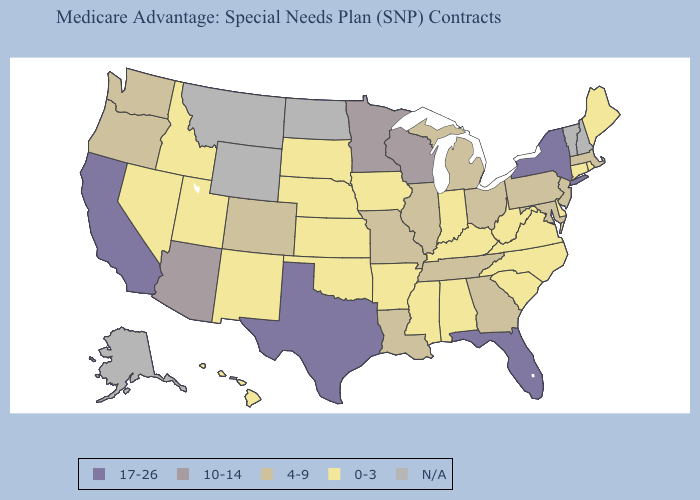What is the value of Kentucky?
Answer briefly. 0-3. Among the states that border Georgia , does Florida have the highest value?
Keep it brief. Yes. Does Florida have the lowest value in the USA?
Short answer required. No. What is the lowest value in states that border West Virginia?
Quick response, please. 0-3. Which states have the lowest value in the West?
Give a very brief answer. Hawaii, Idaho, New Mexico, Nevada, Utah. Name the states that have a value in the range 17-26?
Short answer required. California, Florida, New York, Texas. Name the states that have a value in the range N/A?
Keep it brief. Alaska, Montana, North Dakota, New Hampshire, Vermont, Wyoming. Does the map have missing data?
Short answer required. Yes. Which states have the lowest value in the MidWest?
Write a very short answer. Iowa, Indiana, Kansas, Nebraska, South Dakota. What is the highest value in states that border Mississippi?
Answer briefly. 4-9. Name the states that have a value in the range N/A?
Concise answer only. Alaska, Montana, North Dakota, New Hampshire, Vermont, Wyoming. What is the lowest value in states that border Alabama?
Answer briefly. 0-3. What is the value of Nebraska?
Answer briefly. 0-3. Among the states that border Illinois , which have the highest value?
Keep it brief. Wisconsin. What is the value of Maryland?
Give a very brief answer. 4-9. 